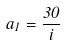Convert formula to latex. <formula><loc_0><loc_0><loc_500><loc_500>a _ { 1 } = \frac { 3 0 } { i }</formula> 